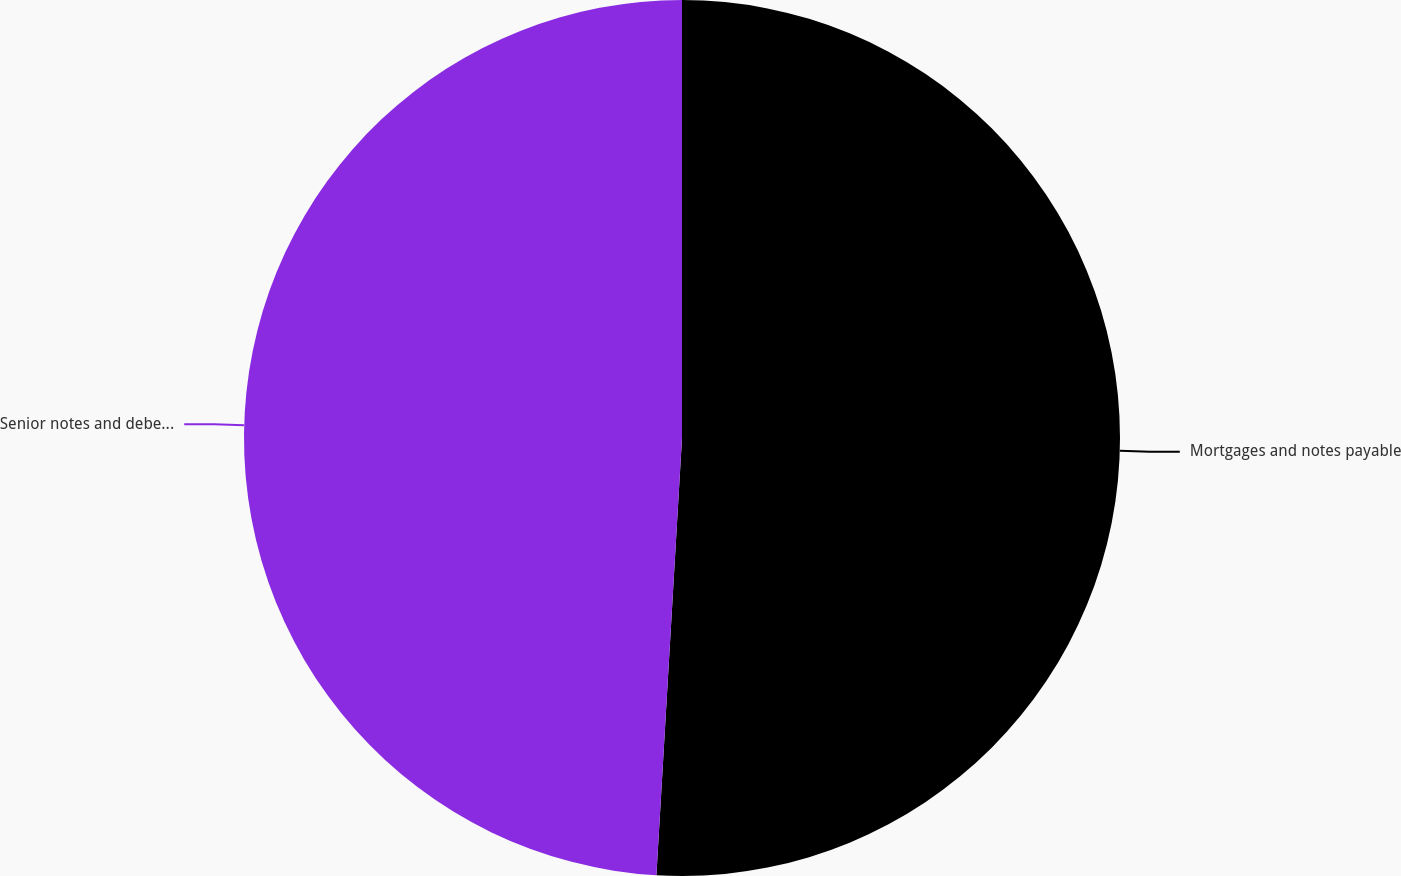<chart> <loc_0><loc_0><loc_500><loc_500><pie_chart><fcel>Mortgages and notes payable<fcel>Senior notes and debentures<nl><fcel>50.93%<fcel>49.07%<nl></chart> 